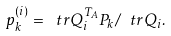Convert formula to latex. <formula><loc_0><loc_0><loc_500><loc_500>p _ { k } ^ { ( i ) } = \ t r { Q _ { i } ^ { T _ { A } } P _ { k } } / \ t r { Q _ { i } } .</formula> 